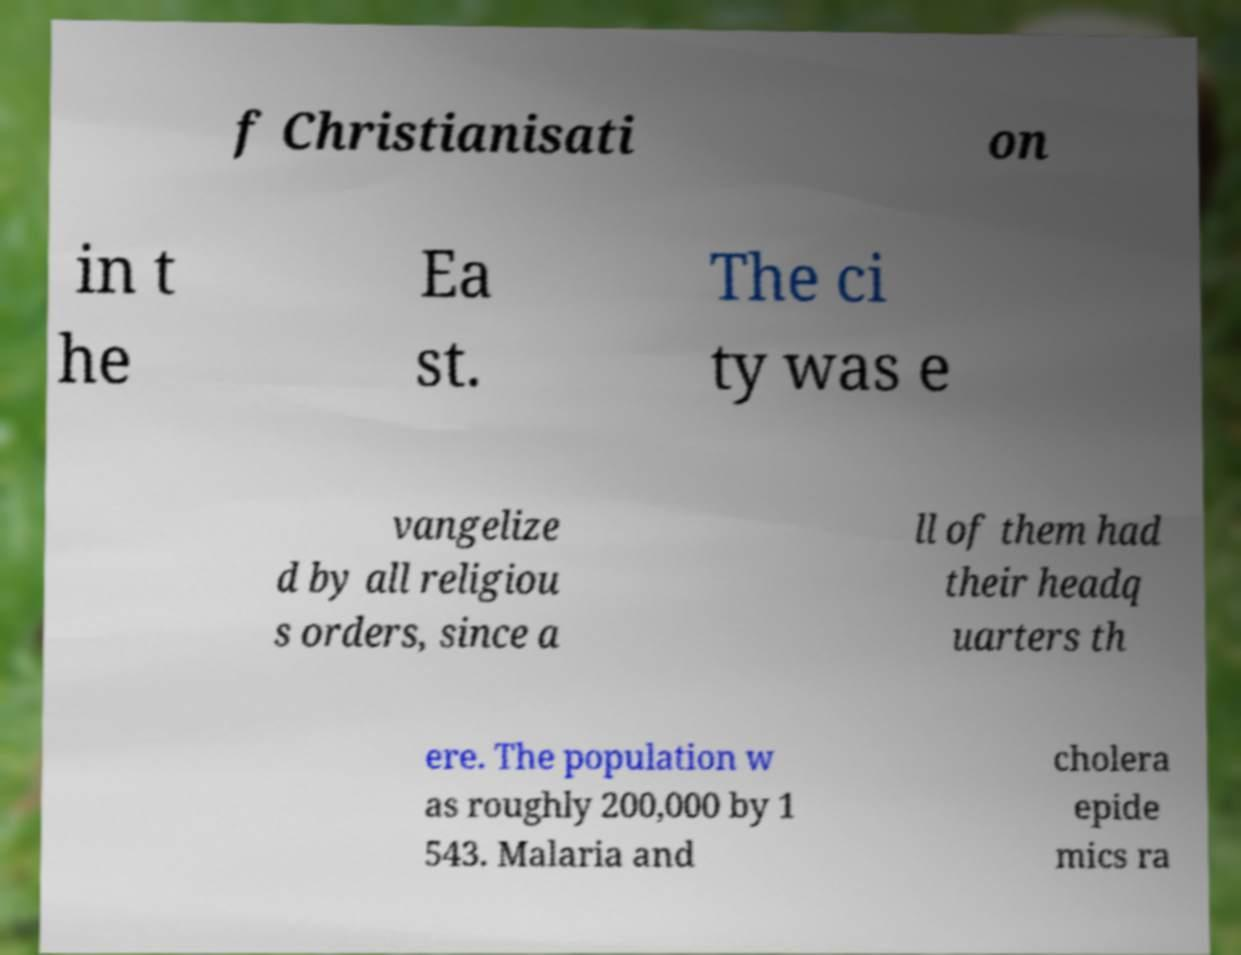Can you read and provide the text displayed in the image?This photo seems to have some interesting text. Can you extract and type it out for me? f Christianisati on in t he Ea st. The ci ty was e vangelize d by all religiou s orders, since a ll of them had their headq uarters th ere. The population w as roughly 200,000 by 1 543. Malaria and cholera epide mics ra 